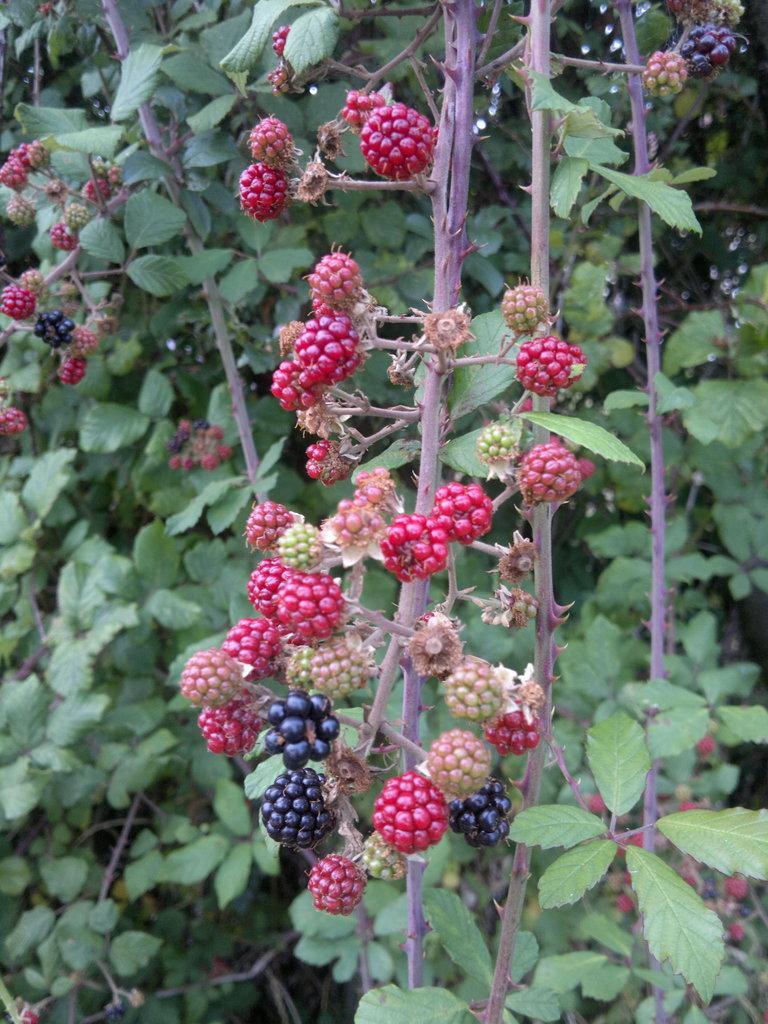Describe this image in one or two sentences. In this picture I can see some fruits to the trees. 